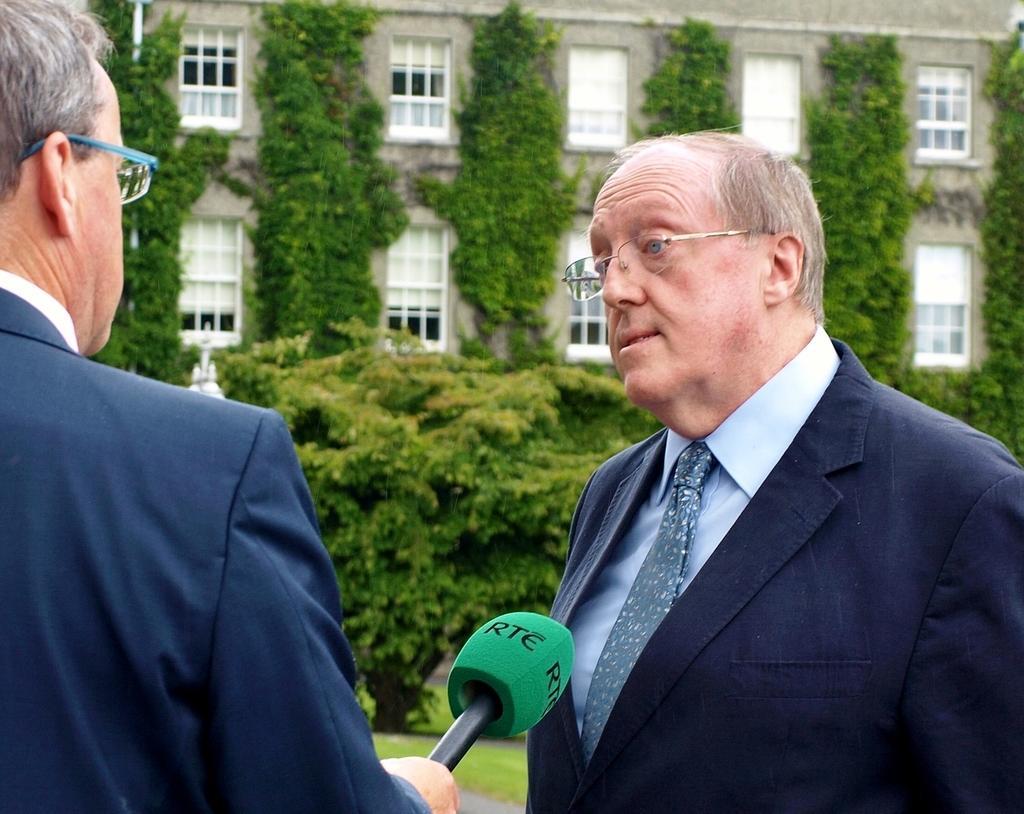Can you describe this image briefly? The two persons are standing. They are wearing spectacles. On the left side of the person is holding a mic. We can see in the background building with wall and tree. 